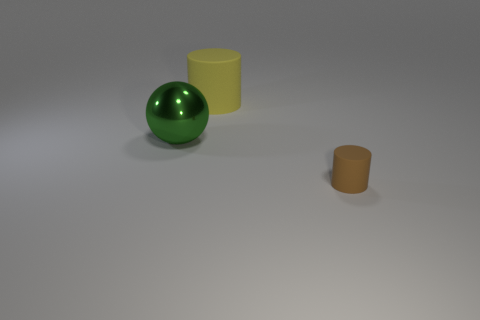Is the material of the large sphere the same as the tiny object?
Provide a short and direct response. No. There is a thing that is on the right side of the metal ball and in front of the yellow matte cylinder; what is its color?
Keep it short and to the point. Brown. Are there any cyan matte objects of the same size as the yellow matte cylinder?
Offer a terse response. No. There is a cylinder to the right of the cylinder that is behind the green metal object; how big is it?
Your answer should be compact. Small. Is the number of green shiny balls behind the large yellow rubber thing less than the number of brown matte blocks?
Provide a short and direct response. No. Is the color of the small cylinder the same as the ball?
Your answer should be very brief. No. How big is the green metallic thing?
Keep it short and to the point. Large. What number of small cylinders have the same color as the metal thing?
Provide a short and direct response. 0. There is a small cylinder that is on the right side of the large object to the left of the big rubber cylinder; are there any brown cylinders that are to the left of it?
Give a very brief answer. No. What is the shape of the rubber thing that is the same size as the shiny thing?
Your response must be concise. Cylinder. 